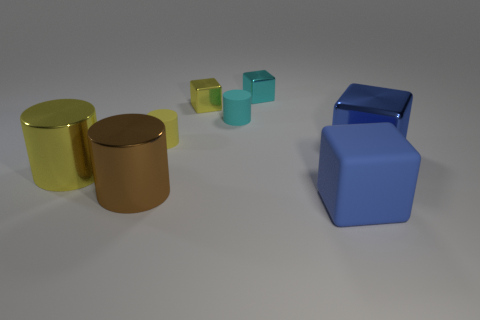There is a thing that is the same color as the big rubber block; what is its shape?
Provide a succinct answer. Cube. How many objects are either cyan rubber cylinders or tiny things?
Offer a very short reply. 4. There is a yellow shiny thing that is to the left of the big brown metal object; is its size the same as the brown shiny object on the left side of the blue rubber block?
Keep it short and to the point. Yes. How many objects are yellow objects that are behind the tiny cyan matte cylinder or yellow things in front of the yellow shiny cube?
Keep it short and to the point. 3. Does the tiny yellow cube have the same material as the tiny cyan thing that is on the left side of the cyan shiny thing?
Keep it short and to the point. No. What number of other objects are there of the same shape as the large brown object?
Give a very brief answer. 3. What is the big cube on the left side of the large metal object to the right of the tiny cyan thing behind the yellow cube made of?
Offer a terse response. Rubber. Are there the same number of large cylinders that are behind the yellow shiny cylinder and small cyan shiny things?
Provide a short and direct response. No. Are the tiny yellow thing that is to the right of the tiny yellow rubber cylinder and the tiny cyan object that is left of the tiny cyan metal block made of the same material?
Offer a very short reply. No. Are there any other things that are the same material as the cyan cylinder?
Make the answer very short. Yes. 